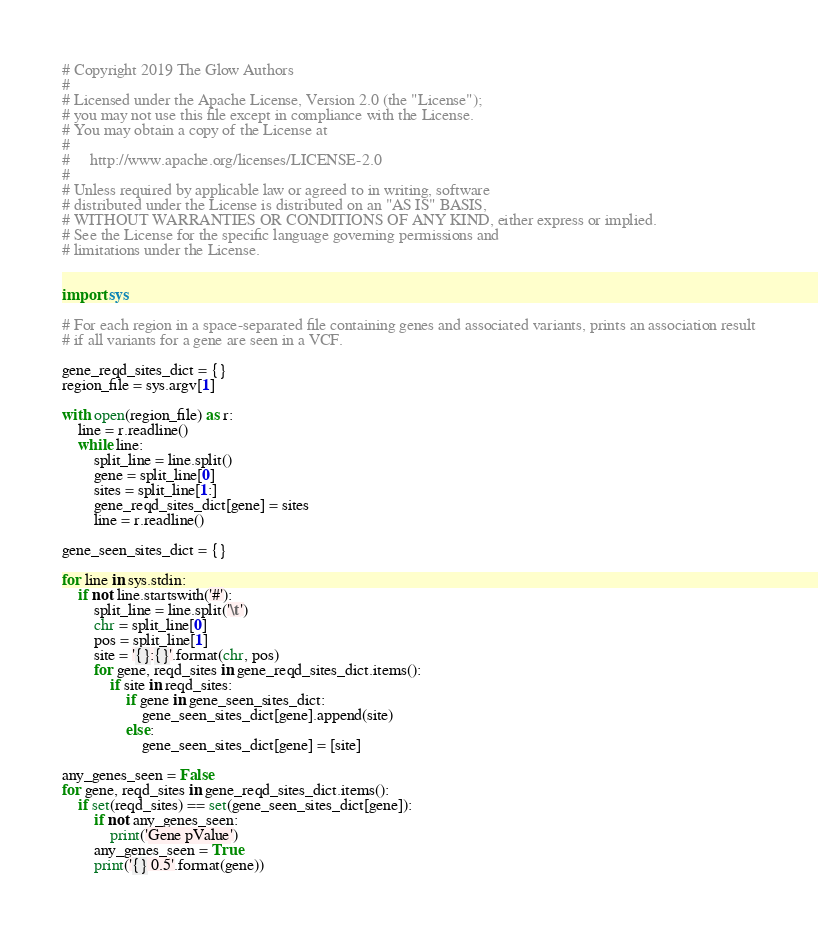Convert code to text. <code><loc_0><loc_0><loc_500><loc_500><_Python_># Copyright 2019 The Glow Authors
# 
# Licensed under the Apache License, Version 2.0 (the "License");
# you may not use this file except in compliance with the License.
# You may obtain a copy of the License at
# 
#     http://www.apache.org/licenses/LICENSE-2.0
# 
# Unless required by applicable law or agreed to in writing, software
# distributed under the License is distributed on an "AS IS" BASIS,
# WITHOUT WARRANTIES OR CONDITIONS OF ANY KIND, either express or implied.
# See the License for the specific language governing permissions and
# limitations under the License.


import sys

# For each region in a space-separated file containing genes and associated variants, prints an association result
# if all variants for a gene are seen in a VCF.

gene_reqd_sites_dict = {}
region_file = sys.argv[1]

with open(region_file) as r:
    line = r.readline()
    while line:
        split_line = line.split()
        gene = split_line[0]
        sites = split_line[1:]
        gene_reqd_sites_dict[gene] = sites
        line = r.readline()

gene_seen_sites_dict = {}

for line in sys.stdin:
    if not line.startswith('#'):
        split_line = line.split('\t')
        chr = split_line[0]
        pos = split_line[1]
        site = '{}:{}'.format(chr, pos)
        for gene, reqd_sites in gene_reqd_sites_dict.items():
            if site in reqd_sites:
                if gene in gene_seen_sites_dict:
                    gene_seen_sites_dict[gene].append(site)
                else:
                    gene_seen_sites_dict[gene] = [site]

any_genes_seen = False
for gene, reqd_sites in gene_reqd_sites_dict.items():
    if set(reqd_sites) == set(gene_seen_sites_dict[gene]):
        if not any_genes_seen:
            print('Gene pValue')
        any_genes_seen = True
        print('{} 0.5'.format(gene))
</code> 